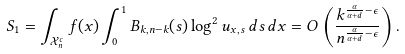Convert formula to latex. <formula><loc_0><loc_0><loc_500><loc_500>S _ { 1 } = \int _ { \mathcal { X } _ { n } ^ { c } } f ( x ) \int _ { 0 } ^ { 1 } B _ { k , n - k } ( s ) \log ^ { 2 } u _ { x , s } \, d s \, d x = O \left ( \frac { k ^ { \frac { \alpha } { \alpha + d } - \epsilon } } { n ^ { \frac { \alpha } { \alpha + d } - \epsilon } } \right ) .</formula> 